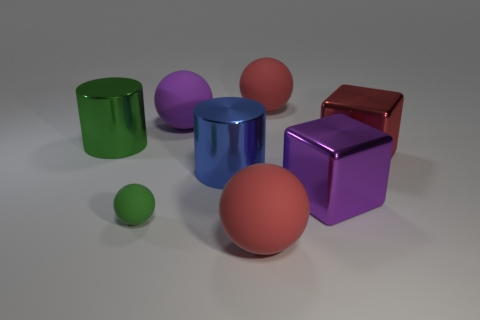What number of metallic blocks are the same color as the tiny object?
Keep it short and to the point. 0. There is a green rubber object in front of the large purple metal object; is it the same shape as the purple shiny thing?
Provide a succinct answer. No. Are there fewer large red matte objects behind the blue thing than big purple things that are left of the large green metallic thing?
Make the answer very short. No. What is the material of the large purple object behind the large blue cylinder?
Make the answer very short. Rubber. What is the size of the other thing that is the same color as the small thing?
Your response must be concise. Large. Are there any red metal blocks of the same size as the green metal thing?
Offer a very short reply. Yes. There is a blue metal object; is its shape the same as the shiny thing to the left of the tiny green thing?
Your response must be concise. Yes. Is the size of the shiny cube on the left side of the red cube the same as the thing that is in front of the tiny green rubber object?
Provide a succinct answer. Yes. How many other things are there of the same shape as the big red shiny thing?
Give a very brief answer. 1. What material is the big purple thing behind the shiny thing that is to the right of the purple metal thing?
Your answer should be very brief. Rubber. 